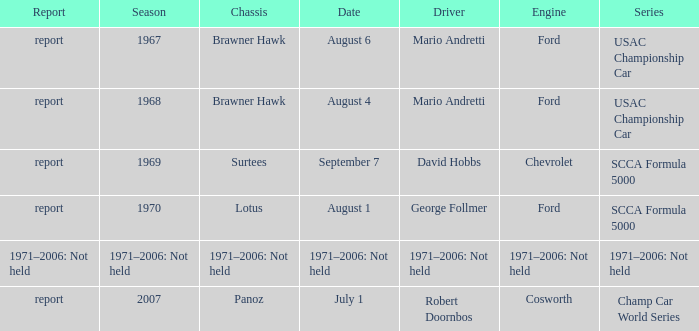Which engine is responsible for the USAC Championship Car? Ford, Ford. 